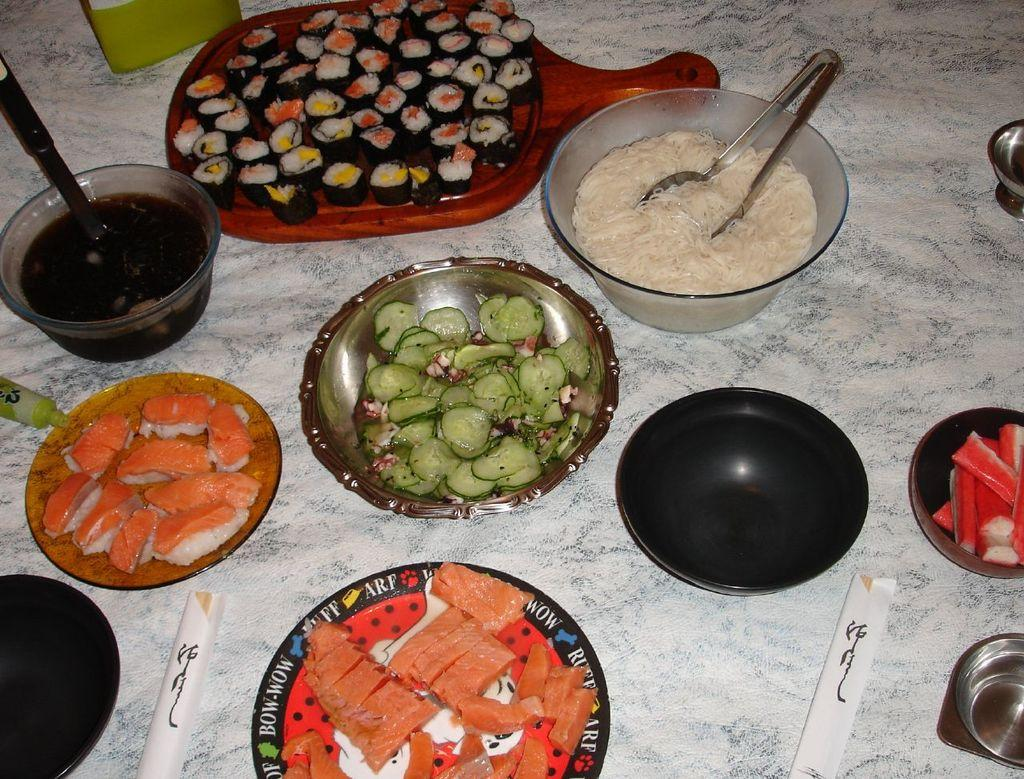What type of dishware can be seen in the image? There are plates and bowls in the image. What are the plates and bowls used for? The plates and bowls contain food items. How many trees are visible in the image? There are no trees visible in the image; it only contains plates and bowls with food items. What type of force is being applied to the food in the image? There is no force being applied to the food in the image; the food is simply contained within the plates and bowls. 